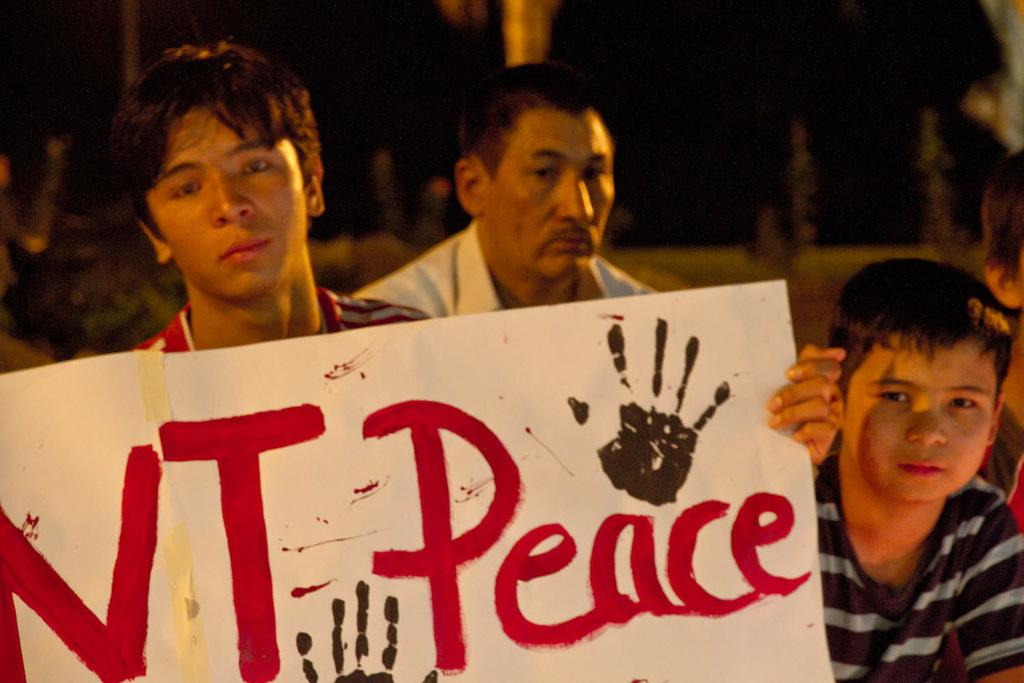How many people are in the image? There are four persons in the image. What is one person doing in the image? One person is holding a board with text. What can be observed about the lighting in the image? The background of the image is dark. What type of flowers can be seen in the image? There are no flowers present in the image. What celestial object is visible in the image? There is no star visible in the image. 